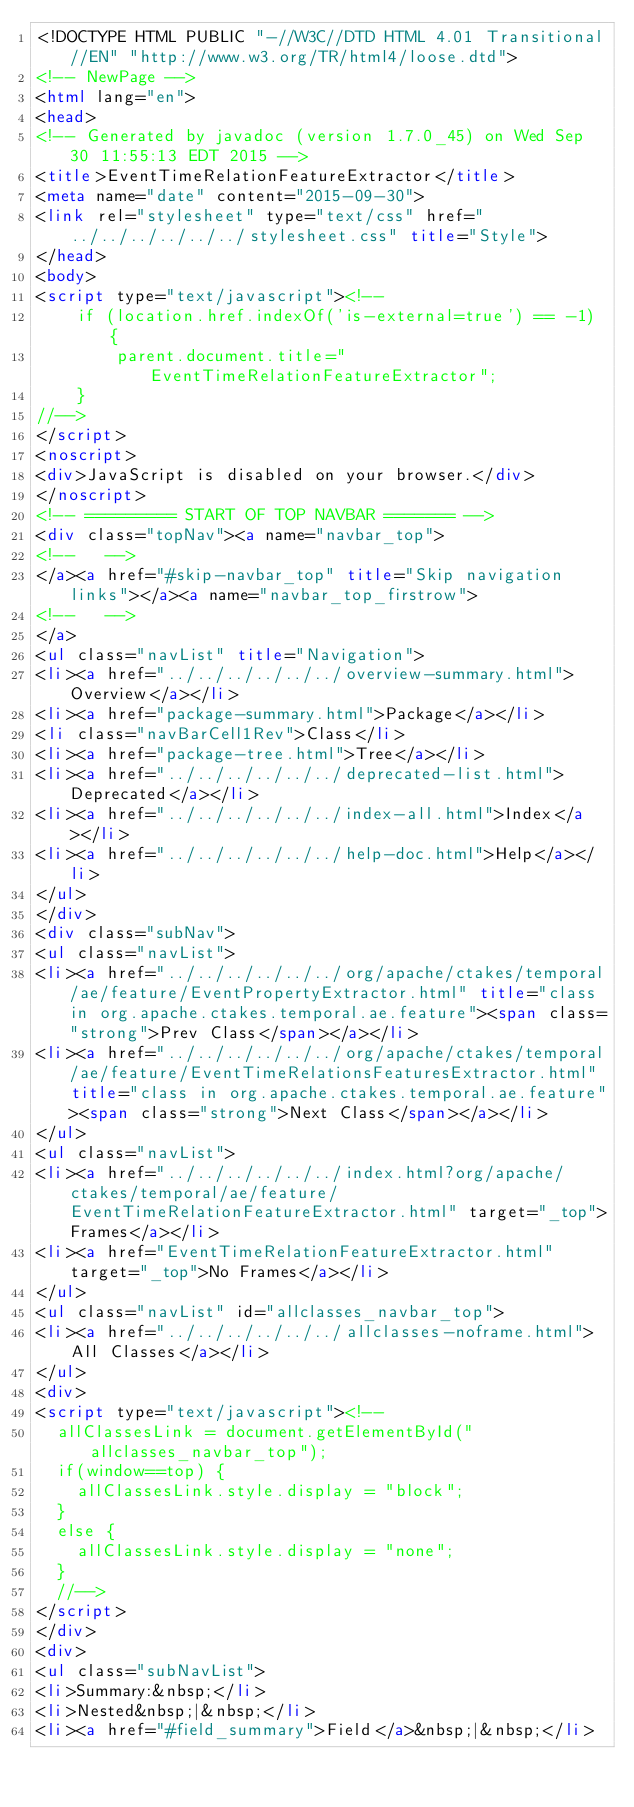Convert code to text. <code><loc_0><loc_0><loc_500><loc_500><_HTML_><!DOCTYPE HTML PUBLIC "-//W3C//DTD HTML 4.01 Transitional//EN" "http://www.w3.org/TR/html4/loose.dtd">
<!-- NewPage -->
<html lang="en">
<head>
<!-- Generated by javadoc (version 1.7.0_45) on Wed Sep 30 11:55:13 EDT 2015 -->
<title>EventTimeRelationFeatureExtractor</title>
<meta name="date" content="2015-09-30">
<link rel="stylesheet" type="text/css" href="../../../../../../stylesheet.css" title="Style">
</head>
<body>
<script type="text/javascript"><!--
    if (location.href.indexOf('is-external=true') == -1) {
        parent.document.title="EventTimeRelationFeatureExtractor";
    }
//-->
</script>
<noscript>
<div>JavaScript is disabled on your browser.</div>
</noscript>
<!-- ========= START OF TOP NAVBAR ======= -->
<div class="topNav"><a name="navbar_top">
<!--   -->
</a><a href="#skip-navbar_top" title="Skip navigation links"></a><a name="navbar_top_firstrow">
<!--   -->
</a>
<ul class="navList" title="Navigation">
<li><a href="../../../../../../overview-summary.html">Overview</a></li>
<li><a href="package-summary.html">Package</a></li>
<li class="navBarCell1Rev">Class</li>
<li><a href="package-tree.html">Tree</a></li>
<li><a href="../../../../../../deprecated-list.html">Deprecated</a></li>
<li><a href="../../../../../../index-all.html">Index</a></li>
<li><a href="../../../../../../help-doc.html">Help</a></li>
</ul>
</div>
<div class="subNav">
<ul class="navList">
<li><a href="../../../../../../org/apache/ctakes/temporal/ae/feature/EventPropertyExtractor.html" title="class in org.apache.ctakes.temporal.ae.feature"><span class="strong">Prev Class</span></a></li>
<li><a href="../../../../../../org/apache/ctakes/temporal/ae/feature/EventTimeRelationsFeaturesExtractor.html" title="class in org.apache.ctakes.temporal.ae.feature"><span class="strong">Next Class</span></a></li>
</ul>
<ul class="navList">
<li><a href="../../../../../../index.html?org/apache/ctakes/temporal/ae/feature/EventTimeRelationFeatureExtractor.html" target="_top">Frames</a></li>
<li><a href="EventTimeRelationFeatureExtractor.html" target="_top">No Frames</a></li>
</ul>
<ul class="navList" id="allclasses_navbar_top">
<li><a href="../../../../../../allclasses-noframe.html">All Classes</a></li>
</ul>
<div>
<script type="text/javascript"><!--
  allClassesLink = document.getElementById("allclasses_navbar_top");
  if(window==top) {
    allClassesLink.style.display = "block";
  }
  else {
    allClassesLink.style.display = "none";
  }
  //-->
</script>
</div>
<div>
<ul class="subNavList">
<li>Summary:&nbsp;</li>
<li>Nested&nbsp;|&nbsp;</li>
<li><a href="#field_summary">Field</a>&nbsp;|&nbsp;</li></code> 